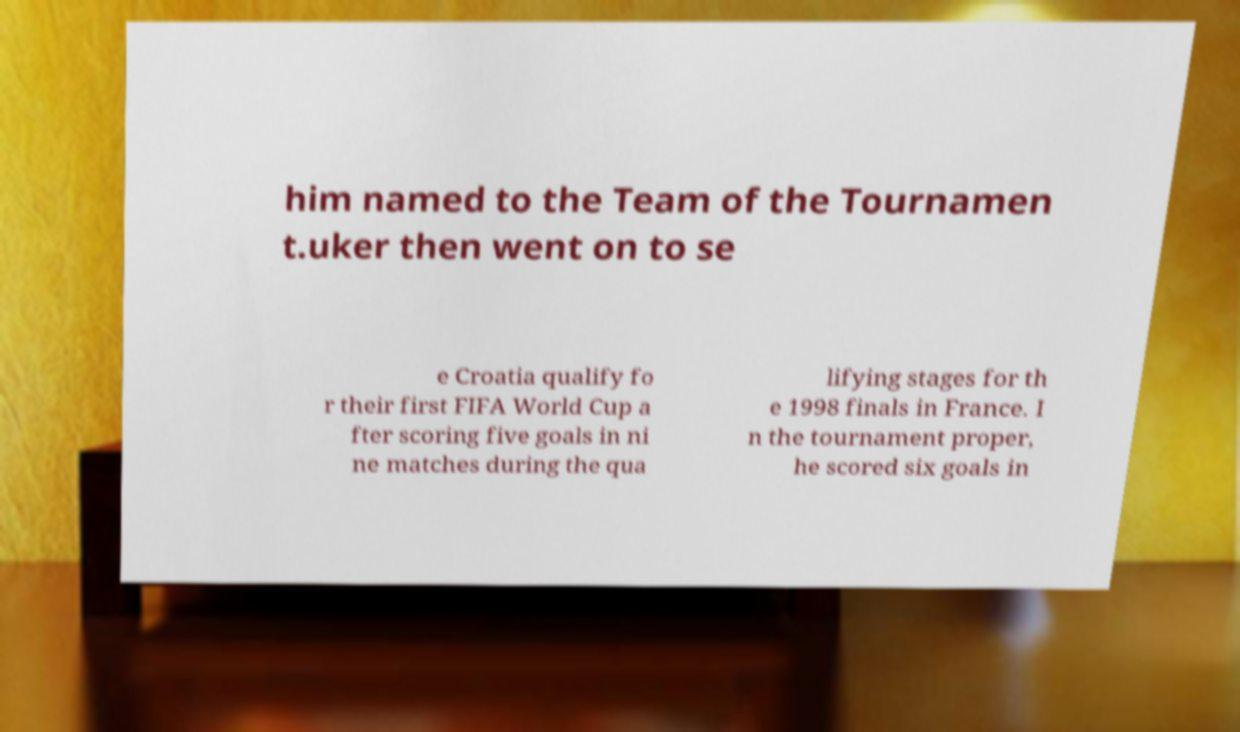There's text embedded in this image that I need extracted. Can you transcribe it verbatim? him named to the Team of the Tournamen t.uker then went on to se e Croatia qualify fo r their first FIFA World Cup a fter scoring five goals in ni ne matches during the qua lifying stages for th e 1998 finals in France. I n the tournament proper, he scored six goals in 